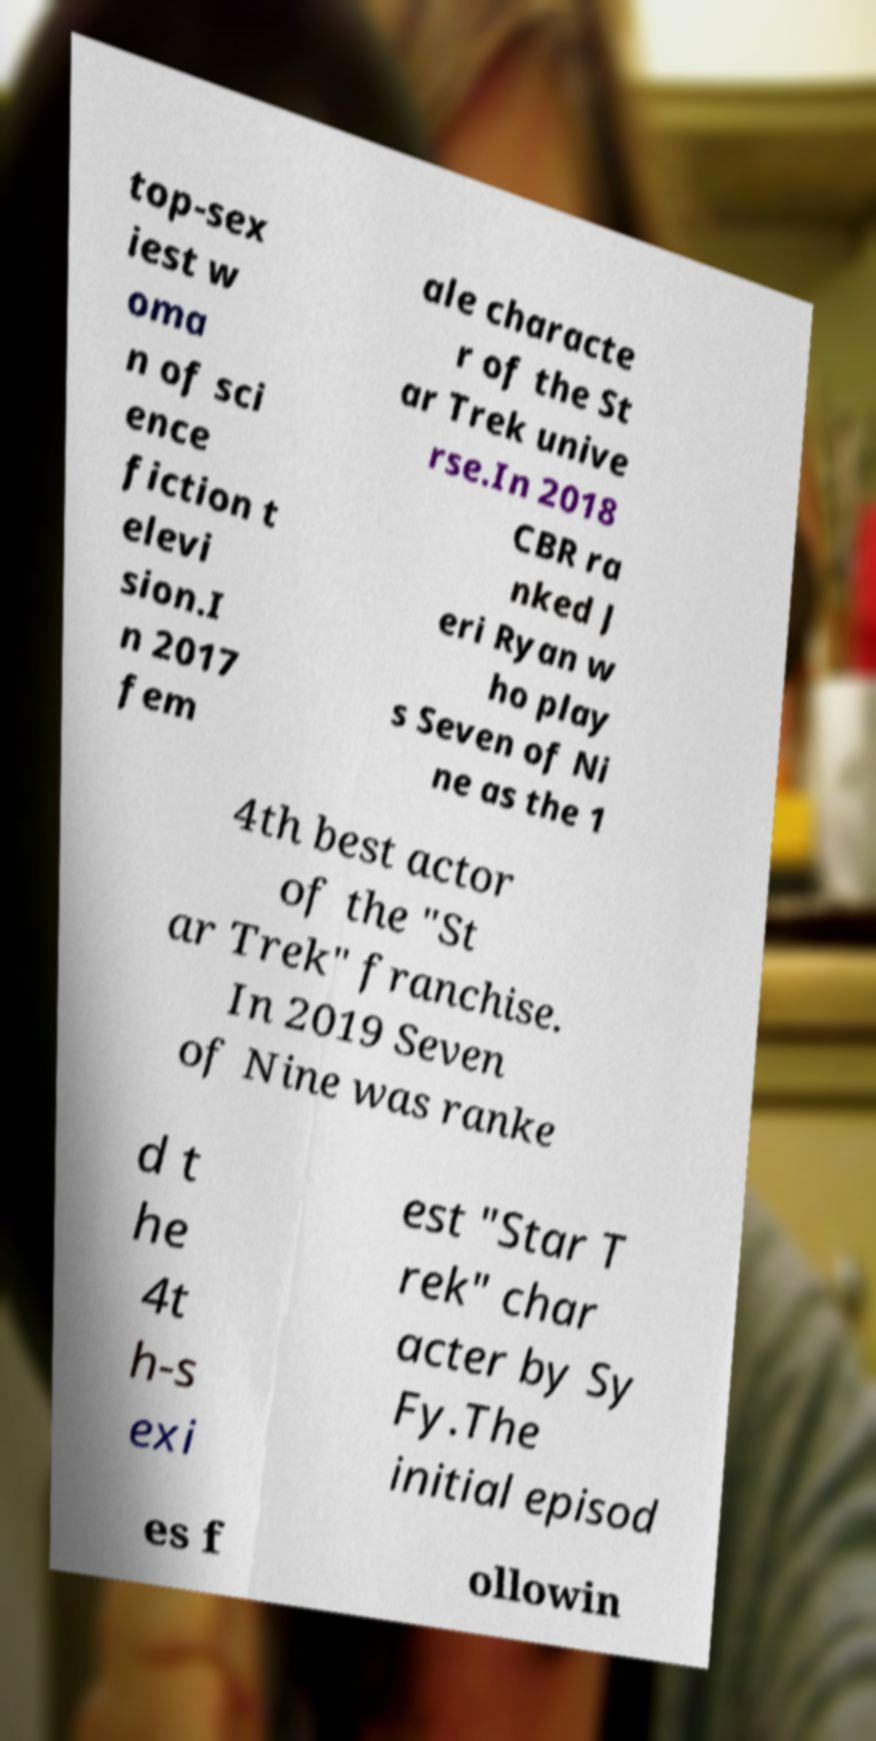Could you extract and type out the text from this image? top-sex iest w oma n of sci ence fiction t elevi sion.I n 2017 fem ale characte r of the St ar Trek unive rse.In 2018 CBR ra nked J eri Ryan w ho play s Seven of Ni ne as the 1 4th best actor of the "St ar Trek" franchise. In 2019 Seven of Nine was ranke d t he 4t h-s exi est "Star T rek" char acter by Sy Fy.The initial episod es f ollowin 